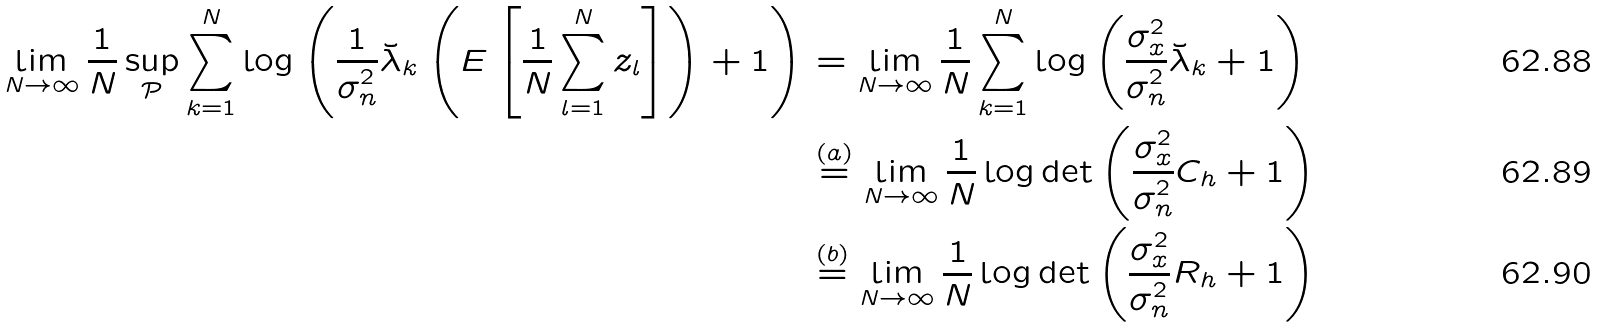<formula> <loc_0><loc_0><loc_500><loc_500>\lim _ { N \rightarrow \infty } \frac { 1 } { N } \sup _ { \mathcal { P } } \sum _ { k = 1 } ^ { N } \log \left ( \frac { 1 } { \sigma _ { n } ^ { 2 } } \breve { \lambda } _ { k } \left ( E \left [ \frac { 1 } { N } \sum _ { l = 1 } ^ { N } z _ { l } \right ] \right ) + 1 \right ) & = \lim _ { N \rightarrow \infty } \frac { 1 } { N } \sum _ { k = 1 } ^ { N } \log \left ( \frac { \sigma _ { x } ^ { 2 } } { \sigma _ { n } ^ { 2 } } \breve { \lambda } _ { k } + 1 \right ) \\ & \stackrel { ( a ) } { = } \lim _ { N \rightarrow \infty } \frac { 1 } { N } \log \det \left ( \frac { \sigma _ { x } ^ { 2 } } { \sigma _ { n } ^ { 2 } } C _ { h } + 1 \right ) \\ & \stackrel { ( b ) } { = } \lim _ { N \rightarrow \infty } \frac { 1 } { N } \log \det \left ( \frac { \sigma _ { x } ^ { 2 } } { \sigma _ { n } ^ { 2 } } R _ { h } + 1 \right )</formula> 